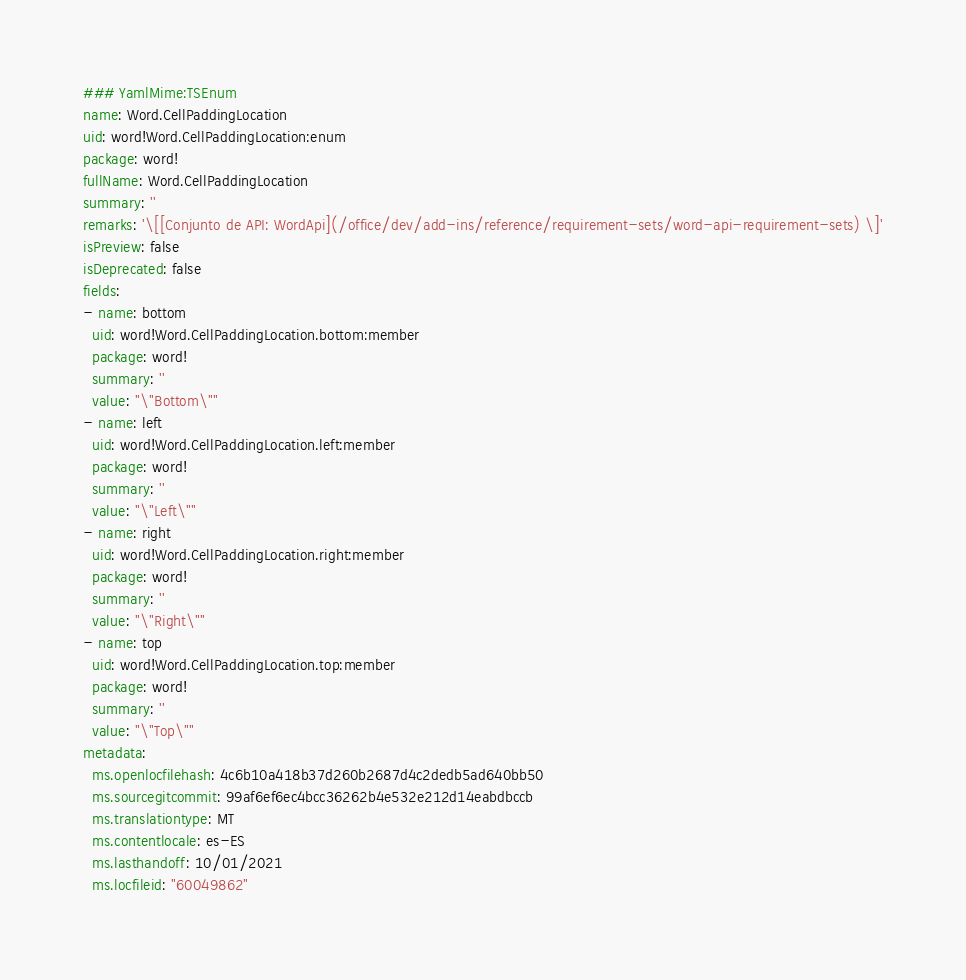<code> <loc_0><loc_0><loc_500><loc_500><_YAML_>### YamlMime:TSEnum
name: Word.CellPaddingLocation
uid: word!Word.CellPaddingLocation:enum
package: word!
fullName: Word.CellPaddingLocation
summary: ''
remarks: '\[[Conjunto de API: WordApi](/office/dev/add-ins/reference/requirement-sets/word-api-requirement-sets) \]'
isPreview: false
isDeprecated: false
fields:
- name: bottom
  uid: word!Word.CellPaddingLocation.bottom:member
  package: word!
  summary: ''
  value: "\"Bottom\""
- name: left
  uid: word!Word.CellPaddingLocation.left:member
  package: word!
  summary: ''
  value: "\"Left\""
- name: right
  uid: word!Word.CellPaddingLocation.right:member
  package: word!
  summary: ''
  value: "\"Right\""
- name: top
  uid: word!Word.CellPaddingLocation.top:member
  package: word!
  summary: ''
  value: "\"Top\""
metadata:
  ms.openlocfilehash: 4c6b10a418b37d260b2687d4c2dedb5ad640bb50
  ms.sourcegitcommit: 99af6ef6ec4bcc36262b4e532e212d14eabdbccb
  ms.translationtype: MT
  ms.contentlocale: es-ES
  ms.lasthandoff: 10/01/2021
  ms.locfileid: "60049862"
</code> 